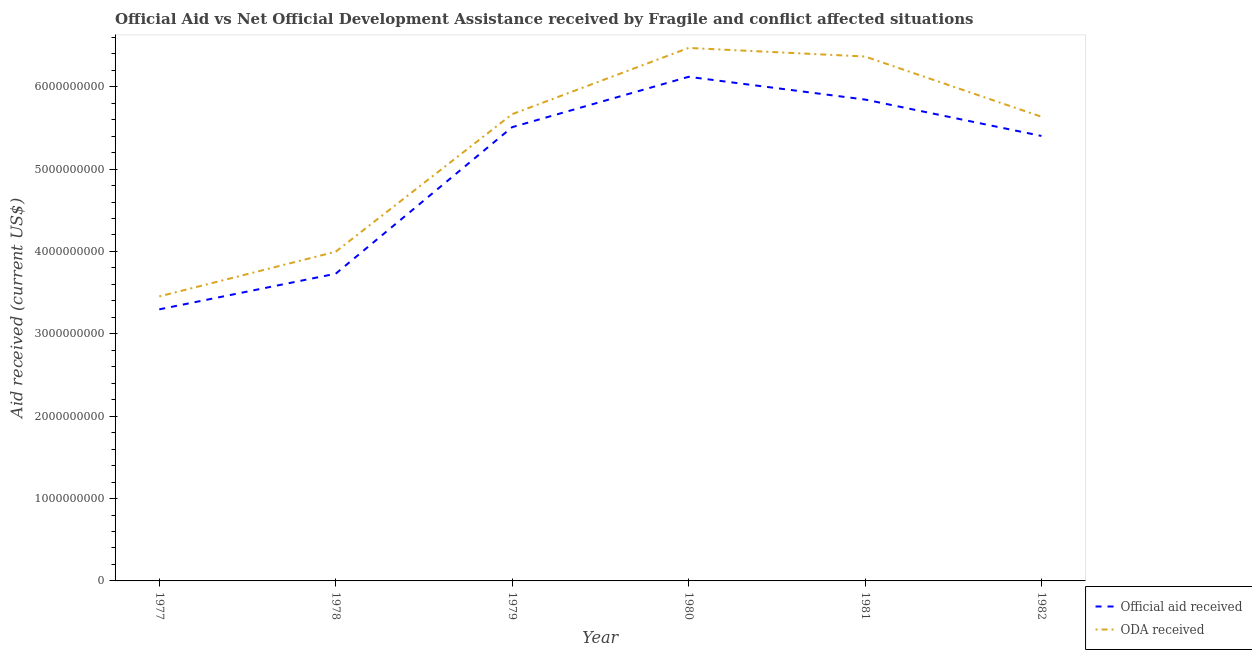Does the line corresponding to official aid received intersect with the line corresponding to oda received?
Offer a terse response. No. Is the number of lines equal to the number of legend labels?
Make the answer very short. Yes. What is the official aid received in 1978?
Offer a terse response. 3.73e+09. Across all years, what is the maximum oda received?
Make the answer very short. 6.47e+09. Across all years, what is the minimum oda received?
Provide a succinct answer. 3.45e+09. In which year was the oda received minimum?
Give a very brief answer. 1977. What is the total oda received in the graph?
Your answer should be compact. 3.16e+1. What is the difference between the official aid received in 1977 and that in 1979?
Your answer should be very brief. -2.21e+09. What is the difference between the official aid received in 1982 and the oda received in 1981?
Provide a succinct answer. -9.64e+08. What is the average oda received per year?
Give a very brief answer. 5.27e+09. In the year 1978, what is the difference between the oda received and official aid received?
Provide a short and direct response. 2.67e+08. In how many years, is the official aid received greater than 5000000000 US$?
Your answer should be very brief. 4. What is the ratio of the official aid received in 1977 to that in 1978?
Offer a very short reply. 0.88. Is the oda received in 1979 less than that in 1981?
Your answer should be compact. Yes. What is the difference between the highest and the second highest official aid received?
Your response must be concise. 2.76e+08. What is the difference between the highest and the lowest official aid received?
Your response must be concise. 2.82e+09. In how many years, is the oda received greater than the average oda received taken over all years?
Your response must be concise. 4. Is the sum of the oda received in 1980 and 1982 greater than the maximum official aid received across all years?
Keep it short and to the point. Yes. What is the difference between two consecutive major ticks on the Y-axis?
Offer a very short reply. 1.00e+09. Does the graph contain any zero values?
Ensure brevity in your answer.  No. Does the graph contain grids?
Offer a very short reply. No. How many legend labels are there?
Keep it short and to the point. 2. How are the legend labels stacked?
Offer a very short reply. Vertical. What is the title of the graph?
Provide a succinct answer. Official Aid vs Net Official Development Assistance received by Fragile and conflict affected situations . Does "Female labor force" appear as one of the legend labels in the graph?
Make the answer very short. No. What is the label or title of the Y-axis?
Offer a terse response. Aid received (current US$). What is the Aid received (current US$) in Official aid received in 1977?
Keep it short and to the point. 3.30e+09. What is the Aid received (current US$) of ODA received in 1977?
Your response must be concise. 3.45e+09. What is the Aid received (current US$) of Official aid received in 1978?
Your answer should be very brief. 3.73e+09. What is the Aid received (current US$) of ODA received in 1978?
Give a very brief answer. 4.00e+09. What is the Aid received (current US$) of Official aid received in 1979?
Offer a terse response. 5.51e+09. What is the Aid received (current US$) in ODA received in 1979?
Provide a short and direct response. 5.67e+09. What is the Aid received (current US$) of Official aid received in 1980?
Provide a succinct answer. 6.12e+09. What is the Aid received (current US$) of ODA received in 1980?
Offer a very short reply. 6.47e+09. What is the Aid received (current US$) in Official aid received in 1981?
Ensure brevity in your answer.  5.84e+09. What is the Aid received (current US$) of ODA received in 1981?
Provide a succinct answer. 6.37e+09. What is the Aid received (current US$) in Official aid received in 1982?
Offer a terse response. 5.40e+09. What is the Aid received (current US$) in ODA received in 1982?
Your answer should be very brief. 5.64e+09. Across all years, what is the maximum Aid received (current US$) of Official aid received?
Provide a short and direct response. 6.12e+09. Across all years, what is the maximum Aid received (current US$) in ODA received?
Your answer should be compact. 6.47e+09. Across all years, what is the minimum Aid received (current US$) in Official aid received?
Keep it short and to the point. 3.30e+09. Across all years, what is the minimum Aid received (current US$) in ODA received?
Provide a succinct answer. 3.45e+09. What is the total Aid received (current US$) in Official aid received in the graph?
Offer a very short reply. 2.99e+1. What is the total Aid received (current US$) of ODA received in the graph?
Provide a short and direct response. 3.16e+1. What is the difference between the Aid received (current US$) of Official aid received in 1977 and that in 1978?
Offer a terse response. -4.33e+08. What is the difference between the Aid received (current US$) in ODA received in 1977 and that in 1978?
Ensure brevity in your answer.  -5.43e+08. What is the difference between the Aid received (current US$) of Official aid received in 1977 and that in 1979?
Provide a short and direct response. -2.21e+09. What is the difference between the Aid received (current US$) in ODA received in 1977 and that in 1979?
Offer a terse response. -2.21e+09. What is the difference between the Aid received (current US$) in Official aid received in 1977 and that in 1980?
Provide a short and direct response. -2.82e+09. What is the difference between the Aid received (current US$) of ODA received in 1977 and that in 1980?
Provide a succinct answer. -3.02e+09. What is the difference between the Aid received (current US$) of Official aid received in 1977 and that in 1981?
Ensure brevity in your answer.  -2.55e+09. What is the difference between the Aid received (current US$) in ODA received in 1977 and that in 1981?
Offer a very short reply. -2.91e+09. What is the difference between the Aid received (current US$) of Official aid received in 1977 and that in 1982?
Make the answer very short. -2.11e+09. What is the difference between the Aid received (current US$) of ODA received in 1977 and that in 1982?
Your response must be concise. -2.18e+09. What is the difference between the Aid received (current US$) in Official aid received in 1978 and that in 1979?
Offer a terse response. -1.78e+09. What is the difference between the Aid received (current US$) in ODA received in 1978 and that in 1979?
Your response must be concise. -1.67e+09. What is the difference between the Aid received (current US$) in Official aid received in 1978 and that in 1980?
Provide a short and direct response. -2.39e+09. What is the difference between the Aid received (current US$) of ODA received in 1978 and that in 1980?
Give a very brief answer. -2.47e+09. What is the difference between the Aid received (current US$) in Official aid received in 1978 and that in 1981?
Your answer should be compact. -2.11e+09. What is the difference between the Aid received (current US$) in ODA received in 1978 and that in 1981?
Your answer should be compact. -2.37e+09. What is the difference between the Aid received (current US$) in Official aid received in 1978 and that in 1982?
Give a very brief answer. -1.67e+09. What is the difference between the Aid received (current US$) of ODA received in 1978 and that in 1982?
Ensure brevity in your answer.  -1.64e+09. What is the difference between the Aid received (current US$) of Official aid received in 1979 and that in 1980?
Offer a very short reply. -6.11e+08. What is the difference between the Aid received (current US$) of ODA received in 1979 and that in 1980?
Make the answer very short. -8.04e+08. What is the difference between the Aid received (current US$) in Official aid received in 1979 and that in 1981?
Ensure brevity in your answer.  -3.35e+08. What is the difference between the Aid received (current US$) in ODA received in 1979 and that in 1981?
Provide a short and direct response. -7.00e+08. What is the difference between the Aid received (current US$) in Official aid received in 1979 and that in 1982?
Your answer should be compact. 1.07e+08. What is the difference between the Aid received (current US$) of ODA received in 1979 and that in 1982?
Offer a terse response. 3.12e+07. What is the difference between the Aid received (current US$) of Official aid received in 1980 and that in 1981?
Ensure brevity in your answer.  2.76e+08. What is the difference between the Aid received (current US$) in ODA received in 1980 and that in 1981?
Your answer should be very brief. 1.04e+08. What is the difference between the Aid received (current US$) in Official aid received in 1980 and that in 1982?
Offer a very short reply. 7.18e+08. What is the difference between the Aid received (current US$) in ODA received in 1980 and that in 1982?
Provide a short and direct response. 8.35e+08. What is the difference between the Aid received (current US$) in Official aid received in 1981 and that in 1982?
Provide a succinct answer. 4.42e+08. What is the difference between the Aid received (current US$) in ODA received in 1981 and that in 1982?
Provide a succinct answer. 7.31e+08. What is the difference between the Aid received (current US$) of Official aid received in 1977 and the Aid received (current US$) of ODA received in 1978?
Ensure brevity in your answer.  -7.00e+08. What is the difference between the Aid received (current US$) of Official aid received in 1977 and the Aid received (current US$) of ODA received in 1979?
Keep it short and to the point. -2.37e+09. What is the difference between the Aid received (current US$) of Official aid received in 1977 and the Aid received (current US$) of ODA received in 1980?
Your answer should be very brief. -3.17e+09. What is the difference between the Aid received (current US$) in Official aid received in 1977 and the Aid received (current US$) in ODA received in 1981?
Offer a terse response. -3.07e+09. What is the difference between the Aid received (current US$) in Official aid received in 1977 and the Aid received (current US$) in ODA received in 1982?
Your answer should be compact. -2.34e+09. What is the difference between the Aid received (current US$) in Official aid received in 1978 and the Aid received (current US$) in ODA received in 1979?
Ensure brevity in your answer.  -1.94e+09. What is the difference between the Aid received (current US$) of Official aid received in 1978 and the Aid received (current US$) of ODA received in 1980?
Provide a succinct answer. -2.74e+09. What is the difference between the Aid received (current US$) of Official aid received in 1978 and the Aid received (current US$) of ODA received in 1981?
Provide a short and direct response. -2.64e+09. What is the difference between the Aid received (current US$) of Official aid received in 1978 and the Aid received (current US$) of ODA received in 1982?
Your response must be concise. -1.91e+09. What is the difference between the Aid received (current US$) in Official aid received in 1979 and the Aid received (current US$) in ODA received in 1980?
Give a very brief answer. -9.62e+08. What is the difference between the Aid received (current US$) in Official aid received in 1979 and the Aid received (current US$) in ODA received in 1981?
Offer a very short reply. -8.58e+08. What is the difference between the Aid received (current US$) in Official aid received in 1979 and the Aid received (current US$) in ODA received in 1982?
Give a very brief answer. -1.27e+08. What is the difference between the Aid received (current US$) in Official aid received in 1980 and the Aid received (current US$) in ODA received in 1981?
Provide a succinct answer. -2.46e+08. What is the difference between the Aid received (current US$) in Official aid received in 1980 and the Aid received (current US$) in ODA received in 1982?
Offer a terse response. 4.85e+08. What is the difference between the Aid received (current US$) in Official aid received in 1981 and the Aid received (current US$) in ODA received in 1982?
Give a very brief answer. 2.09e+08. What is the average Aid received (current US$) in Official aid received per year?
Your answer should be very brief. 4.98e+09. What is the average Aid received (current US$) of ODA received per year?
Provide a succinct answer. 5.27e+09. In the year 1977, what is the difference between the Aid received (current US$) in Official aid received and Aid received (current US$) in ODA received?
Ensure brevity in your answer.  -1.57e+08. In the year 1978, what is the difference between the Aid received (current US$) in Official aid received and Aid received (current US$) in ODA received?
Provide a short and direct response. -2.67e+08. In the year 1979, what is the difference between the Aid received (current US$) of Official aid received and Aid received (current US$) of ODA received?
Offer a very short reply. -1.58e+08. In the year 1980, what is the difference between the Aid received (current US$) of Official aid received and Aid received (current US$) of ODA received?
Provide a succinct answer. -3.50e+08. In the year 1981, what is the difference between the Aid received (current US$) of Official aid received and Aid received (current US$) of ODA received?
Your answer should be compact. -5.22e+08. In the year 1982, what is the difference between the Aid received (current US$) of Official aid received and Aid received (current US$) of ODA received?
Offer a very short reply. -2.33e+08. What is the ratio of the Aid received (current US$) of Official aid received in 1977 to that in 1978?
Keep it short and to the point. 0.88. What is the ratio of the Aid received (current US$) in ODA received in 1977 to that in 1978?
Your answer should be compact. 0.86. What is the ratio of the Aid received (current US$) of Official aid received in 1977 to that in 1979?
Give a very brief answer. 0.6. What is the ratio of the Aid received (current US$) in ODA received in 1977 to that in 1979?
Provide a succinct answer. 0.61. What is the ratio of the Aid received (current US$) of Official aid received in 1977 to that in 1980?
Give a very brief answer. 0.54. What is the ratio of the Aid received (current US$) in ODA received in 1977 to that in 1980?
Your response must be concise. 0.53. What is the ratio of the Aid received (current US$) of Official aid received in 1977 to that in 1981?
Your response must be concise. 0.56. What is the ratio of the Aid received (current US$) in ODA received in 1977 to that in 1981?
Provide a succinct answer. 0.54. What is the ratio of the Aid received (current US$) of Official aid received in 1977 to that in 1982?
Give a very brief answer. 0.61. What is the ratio of the Aid received (current US$) in ODA received in 1977 to that in 1982?
Offer a very short reply. 0.61. What is the ratio of the Aid received (current US$) in Official aid received in 1978 to that in 1979?
Provide a short and direct response. 0.68. What is the ratio of the Aid received (current US$) of ODA received in 1978 to that in 1979?
Ensure brevity in your answer.  0.71. What is the ratio of the Aid received (current US$) in Official aid received in 1978 to that in 1980?
Your answer should be compact. 0.61. What is the ratio of the Aid received (current US$) of ODA received in 1978 to that in 1980?
Provide a short and direct response. 0.62. What is the ratio of the Aid received (current US$) in Official aid received in 1978 to that in 1981?
Ensure brevity in your answer.  0.64. What is the ratio of the Aid received (current US$) of ODA received in 1978 to that in 1981?
Your answer should be compact. 0.63. What is the ratio of the Aid received (current US$) of Official aid received in 1978 to that in 1982?
Provide a short and direct response. 0.69. What is the ratio of the Aid received (current US$) of ODA received in 1978 to that in 1982?
Ensure brevity in your answer.  0.71. What is the ratio of the Aid received (current US$) of Official aid received in 1979 to that in 1980?
Make the answer very short. 0.9. What is the ratio of the Aid received (current US$) of ODA received in 1979 to that in 1980?
Provide a succinct answer. 0.88. What is the ratio of the Aid received (current US$) of Official aid received in 1979 to that in 1981?
Keep it short and to the point. 0.94. What is the ratio of the Aid received (current US$) of ODA received in 1979 to that in 1981?
Make the answer very short. 0.89. What is the ratio of the Aid received (current US$) of Official aid received in 1979 to that in 1982?
Your answer should be compact. 1.02. What is the ratio of the Aid received (current US$) in Official aid received in 1980 to that in 1981?
Keep it short and to the point. 1.05. What is the ratio of the Aid received (current US$) of ODA received in 1980 to that in 1981?
Your response must be concise. 1.02. What is the ratio of the Aid received (current US$) of Official aid received in 1980 to that in 1982?
Offer a very short reply. 1.13. What is the ratio of the Aid received (current US$) of ODA received in 1980 to that in 1982?
Keep it short and to the point. 1.15. What is the ratio of the Aid received (current US$) of Official aid received in 1981 to that in 1982?
Ensure brevity in your answer.  1.08. What is the ratio of the Aid received (current US$) in ODA received in 1981 to that in 1982?
Give a very brief answer. 1.13. What is the difference between the highest and the second highest Aid received (current US$) in Official aid received?
Your answer should be very brief. 2.76e+08. What is the difference between the highest and the second highest Aid received (current US$) in ODA received?
Your answer should be compact. 1.04e+08. What is the difference between the highest and the lowest Aid received (current US$) in Official aid received?
Provide a short and direct response. 2.82e+09. What is the difference between the highest and the lowest Aid received (current US$) in ODA received?
Your answer should be very brief. 3.02e+09. 